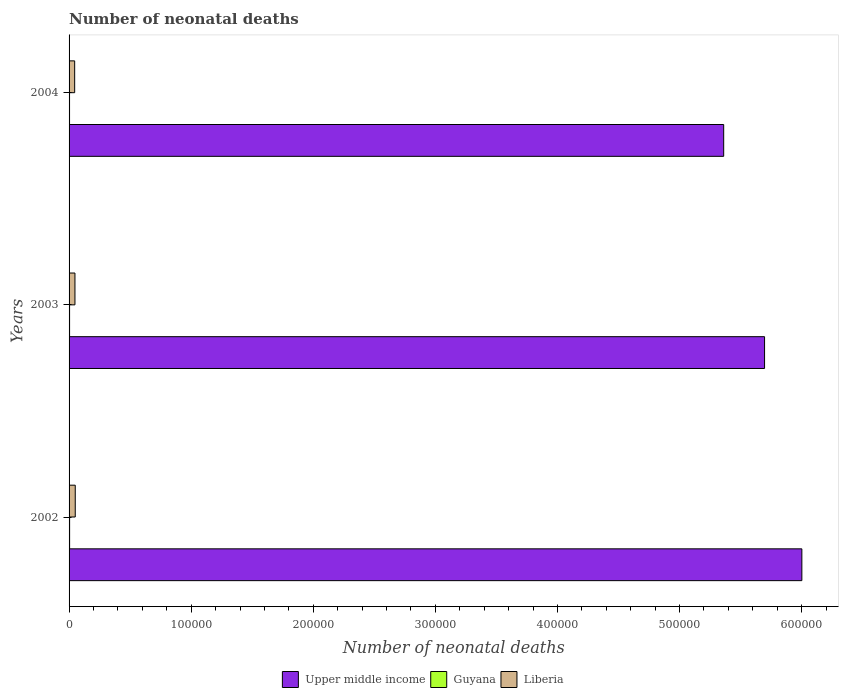How many bars are there on the 2nd tick from the bottom?
Provide a succinct answer. 3. What is the label of the 3rd group of bars from the top?
Your response must be concise. 2002. In how many cases, is the number of bars for a given year not equal to the number of legend labels?
Offer a terse response. 0. What is the number of neonatal deaths in in Liberia in 2002?
Your answer should be compact. 5062. Across all years, what is the maximum number of neonatal deaths in in Upper middle income?
Offer a terse response. 6.00e+05. Across all years, what is the minimum number of neonatal deaths in in Guyana?
Your response must be concise. 394. In which year was the number of neonatal deaths in in Guyana minimum?
Keep it short and to the point. 2004. What is the total number of neonatal deaths in in Liberia in the graph?
Offer a terse response. 1.45e+04. What is the difference between the number of neonatal deaths in in Liberia in 2002 and that in 2004?
Your answer should be compact. 475. What is the difference between the number of neonatal deaths in in Upper middle income in 2004 and the number of neonatal deaths in in Guyana in 2003?
Give a very brief answer. 5.36e+05. What is the average number of neonatal deaths in in Liberia per year?
Give a very brief answer. 4820.33. In the year 2002, what is the difference between the number of neonatal deaths in in Guyana and number of neonatal deaths in in Upper middle income?
Provide a succinct answer. -6.00e+05. In how many years, is the number of neonatal deaths in in Guyana greater than 400000 ?
Your answer should be very brief. 0. What is the ratio of the number of neonatal deaths in in Guyana in 2002 to that in 2003?
Provide a short and direct response. 1.06. Is the difference between the number of neonatal deaths in in Guyana in 2002 and 2003 greater than the difference between the number of neonatal deaths in in Upper middle income in 2002 and 2003?
Keep it short and to the point. No. What is the difference between the highest and the second highest number of neonatal deaths in in Guyana?
Ensure brevity in your answer.  24. What is the difference between the highest and the lowest number of neonatal deaths in in Upper middle income?
Provide a succinct answer. 6.40e+04. What does the 2nd bar from the top in 2003 represents?
Your answer should be very brief. Guyana. What does the 3rd bar from the bottom in 2002 represents?
Your answer should be very brief. Liberia. How many bars are there?
Offer a terse response. 9. Are all the bars in the graph horizontal?
Ensure brevity in your answer.  Yes. How many years are there in the graph?
Ensure brevity in your answer.  3. What is the difference between two consecutive major ticks on the X-axis?
Keep it short and to the point. 1.00e+05. Are the values on the major ticks of X-axis written in scientific E-notation?
Ensure brevity in your answer.  No. Does the graph contain any zero values?
Ensure brevity in your answer.  No. How many legend labels are there?
Give a very brief answer. 3. What is the title of the graph?
Provide a short and direct response. Number of neonatal deaths. Does "St. Kitts and Nevis" appear as one of the legend labels in the graph?
Ensure brevity in your answer.  No. What is the label or title of the X-axis?
Your answer should be compact. Number of neonatal deaths. What is the Number of neonatal deaths of Upper middle income in 2002?
Offer a very short reply. 6.00e+05. What is the Number of neonatal deaths in Guyana in 2002?
Offer a very short reply. 443. What is the Number of neonatal deaths of Liberia in 2002?
Give a very brief answer. 5062. What is the Number of neonatal deaths in Upper middle income in 2003?
Give a very brief answer. 5.70e+05. What is the Number of neonatal deaths in Guyana in 2003?
Ensure brevity in your answer.  419. What is the Number of neonatal deaths of Liberia in 2003?
Your answer should be compact. 4812. What is the Number of neonatal deaths in Upper middle income in 2004?
Ensure brevity in your answer.  5.36e+05. What is the Number of neonatal deaths of Guyana in 2004?
Provide a short and direct response. 394. What is the Number of neonatal deaths of Liberia in 2004?
Your response must be concise. 4587. Across all years, what is the maximum Number of neonatal deaths in Upper middle income?
Offer a very short reply. 6.00e+05. Across all years, what is the maximum Number of neonatal deaths in Guyana?
Your answer should be very brief. 443. Across all years, what is the maximum Number of neonatal deaths of Liberia?
Your answer should be very brief. 5062. Across all years, what is the minimum Number of neonatal deaths in Upper middle income?
Keep it short and to the point. 5.36e+05. Across all years, what is the minimum Number of neonatal deaths in Guyana?
Give a very brief answer. 394. Across all years, what is the minimum Number of neonatal deaths in Liberia?
Your answer should be very brief. 4587. What is the total Number of neonatal deaths of Upper middle income in the graph?
Provide a succinct answer. 1.71e+06. What is the total Number of neonatal deaths of Guyana in the graph?
Offer a very short reply. 1256. What is the total Number of neonatal deaths in Liberia in the graph?
Your answer should be very brief. 1.45e+04. What is the difference between the Number of neonatal deaths in Upper middle income in 2002 and that in 2003?
Your answer should be compact. 3.05e+04. What is the difference between the Number of neonatal deaths in Liberia in 2002 and that in 2003?
Your response must be concise. 250. What is the difference between the Number of neonatal deaths of Upper middle income in 2002 and that in 2004?
Your answer should be very brief. 6.40e+04. What is the difference between the Number of neonatal deaths of Liberia in 2002 and that in 2004?
Offer a very short reply. 475. What is the difference between the Number of neonatal deaths of Upper middle income in 2003 and that in 2004?
Your answer should be very brief. 3.35e+04. What is the difference between the Number of neonatal deaths of Guyana in 2003 and that in 2004?
Your answer should be very brief. 25. What is the difference between the Number of neonatal deaths in Liberia in 2003 and that in 2004?
Your answer should be very brief. 225. What is the difference between the Number of neonatal deaths in Upper middle income in 2002 and the Number of neonatal deaths in Guyana in 2003?
Ensure brevity in your answer.  6.00e+05. What is the difference between the Number of neonatal deaths in Upper middle income in 2002 and the Number of neonatal deaths in Liberia in 2003?
Your response must be concise. 5.95e+05. What is the difference between the Number of neonatal deaths of Guyana in 2002 and the Number of neonatal deaths of Liberia in 2003?
Your answer should be very brief. -4369. What is the difference between the Number of neonatal deaths in Upper middle income in 2002 and the Number of neonatal deaths in Guyana in 2004?
Ensure brevity in your answer.  6.00e+05. What is the difference between the Number of neonatal deaths in Upper middle income in 2002 and the Number of neonatal deaths in Liberia in 2004?
Your answer should be very brief. 5.96e+05. What is the difference between the Number of neonatal deaths in Guyana in 2002 and the Number of neonatal deaths in Liberia in 2004?
Provide a short and direct response. -4144. What is the difference between the Number of neonatal deaths of Upper middle income in 2003 and the Number of neonatal deaths of Guyana in 2004?
Offer a very short reply. 5.69e+05. What is the difference between the Number of neonatal deaths of Upper middle income in 2003 and the Number of neonatal deaths of Liberia in 2004?
Offer a terse response. 5.65e+05. What is the difference between the Number of neonatal deaths of Guyana in 2003 and the Number of neonatal deaths of Liberia in 2004?
Offer a terse response. -4168. What is the average Number of neonatal deaths in Upper middle income per year?
Ensure brevity in your answer.  5.69e+05. What is the average Number of neonatal deaths of Guyana per year?
Provide a succinct answer. 418.67. What is the average Number of neonatal deaths of Liberia per year?
Ensure brevity in your answer.  4820.33. In the year 2002, what is the difference between the Number of neonatal deaths in Upper middle income and Number of neonatal deaths in Guyana?
Offer a terse response. 6.00e+05. In the year 2002, what is the difference between the Number of neonatal deaths in Upper middle income and Number of neonatal deaths in Liberia?
Give a very brief answer. 5.95e+05. In the year 2002, what is the difference between the Number of neonatal deaths in Guyana and Number of neonatal deaths in Liberia?
Offer a very short reply. -4619. In the year 2003, what is the difference between the Number of neonatal deaths of Upper middle income and Number of neonatal deaths of Guyana?
Your response must be concise. 5.69e+05. In the year 2003, what is the difference between the Number of neonatal deaths of Upper middle income and Number of neonatal deaths of Liberia?
Make the answer very short. 5.65e+05. In the year 2003, what is the difference between the Number of neonatal deaths in Guyana and Number of neonatal deaths in Liberia?
Keep it short and to the point. -4393. In the year 2004, what is the difference between the Number of neonatal deaths of Upper middle income and Number of neonatal deaths of Guyana?
Offer a terse response. 5.36e+05. In the year 2004, what is the difference between the Number of neonatal deaths in Upper middle income and Number of neonatal deaths in Liberia?
Provide a succinct answer. 5.32e+05. In the year 2004, what is the difference between the Number of neonatal deaths of Guyana and Number of neonatal deaths of Liberia?
Provide a short and direct response. -4193. What is the ratio of the Number of neonatal deaths in Upper middle income in 2002 to that in 2003?
Give a very brief answer. 1.05. What is the ratio of the Number of neonatal deaths of Guyana in 2002 to that in 2003?
Offer a terse response. 1.06. What is the ratio of the Number of neonatal deaths in Liberia in 2002 to that in 2003?
Offer a very short reply. 1.05. What is the ratio of the Number of neonatal deaths of Upper middle income in 2002 to that in 2004?
Give a very brief answer. 1.12. What is the ratio of the Number of neonatal deaths in Guyana in 2002 to that in 2004?
Offer a terse response. 1.12. What is the ratio of the Number of neonatal deaths of Liberia in 2002 to that in 2004?
Your response must be concise. 1.1. What is the ratio of the Number of neonatal deaths in Guyana in 2003 to that in 2004?
Your answer should be very brief. 1.06. What is the ratio of the Number of neonatal deaths of Liberia in 2003 to that in 2004?
Offer a very short reply. 1.05. What is the difference between the highest and the second highest Number of neonatal deaths in Upper middle income?
Your answer should be very brief. 3.05e+04. What is the difference between the highest and the second highest Number of neonatal deaths of Guyana?
Provide a succinct answer. 24. What is the difference between the highest and the second highest Number of neonatal deaths in Liberia?
Offer a very short reply. 250. What is the difference between the highest and the lowest Number of neonatal deaths of Upper middle income?
Make the answer very short. 6.40e+04. What is the difference between the highest and the lowest Number of neonatal deaths of Liberia?
Ensure brevity in your answer.  475. 